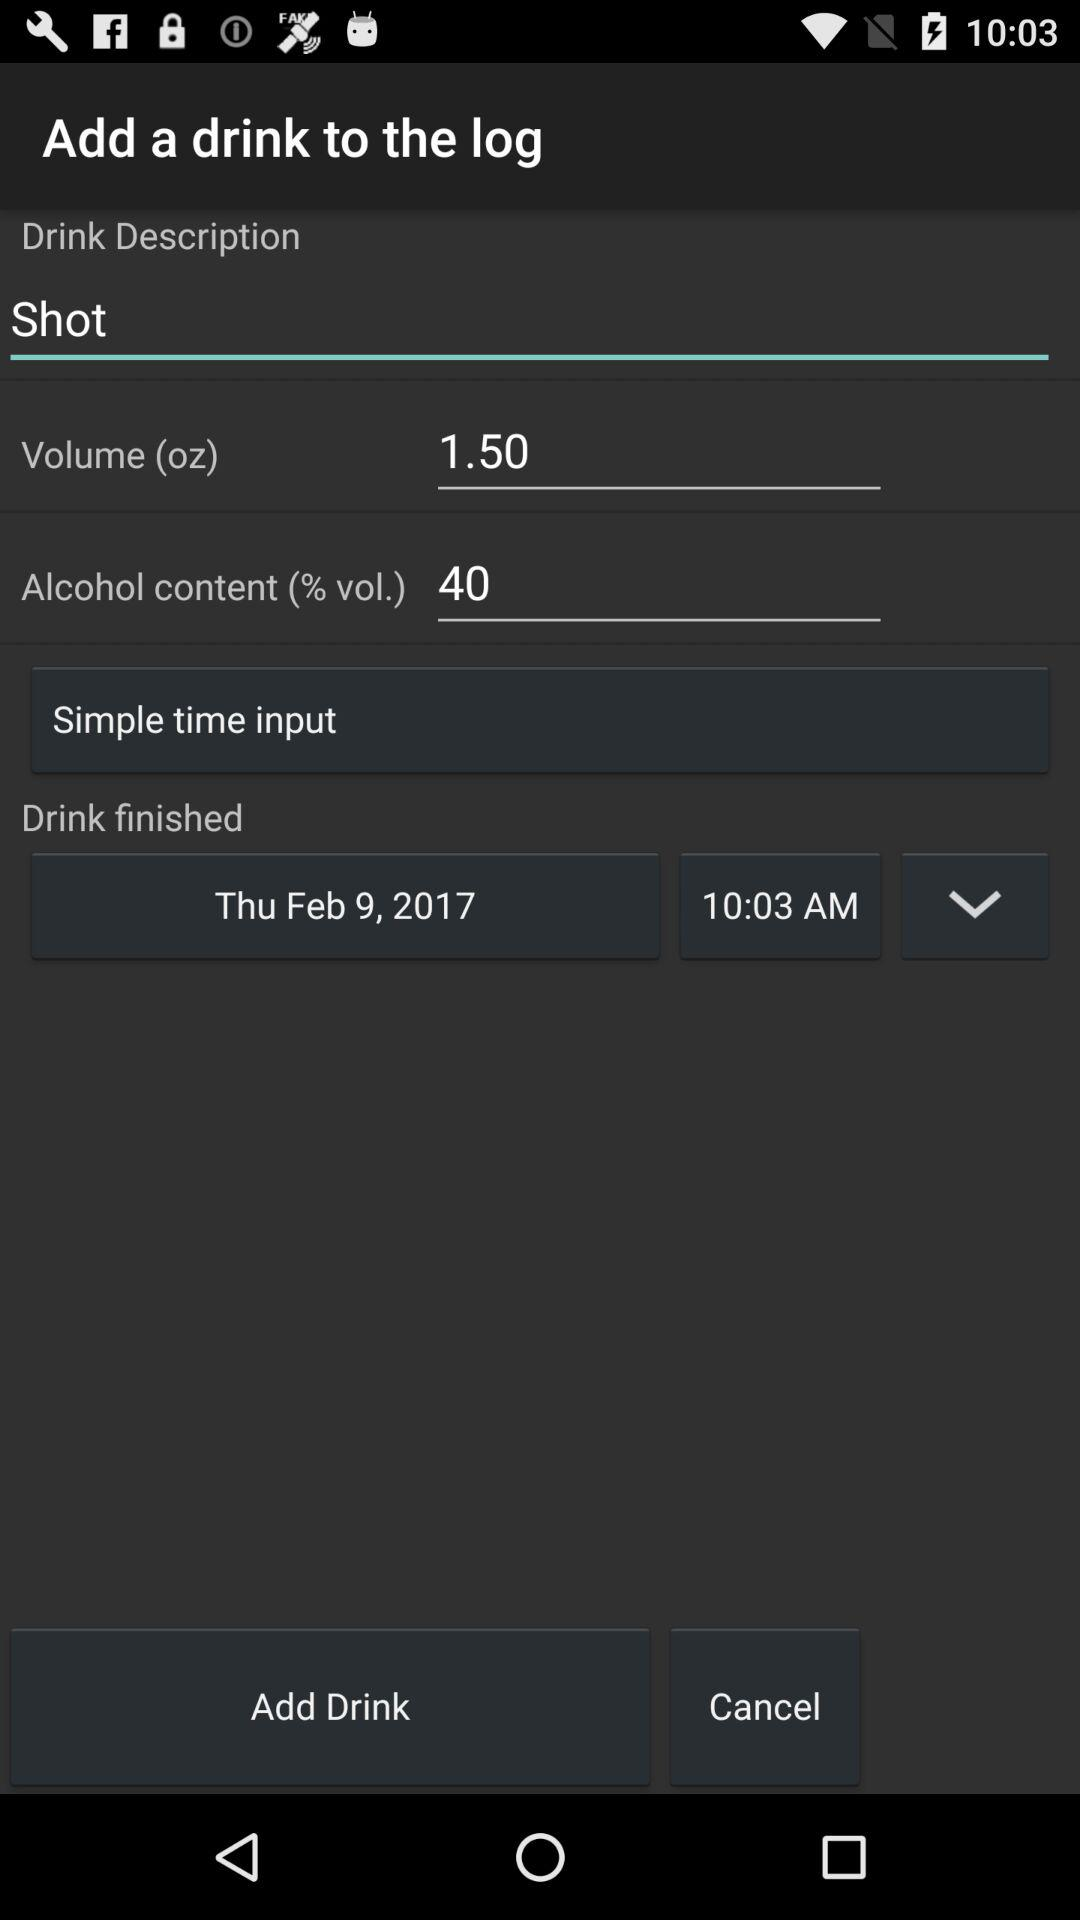What is the mentioned date? The mentioned date is Thursday, February 9, 2017. 